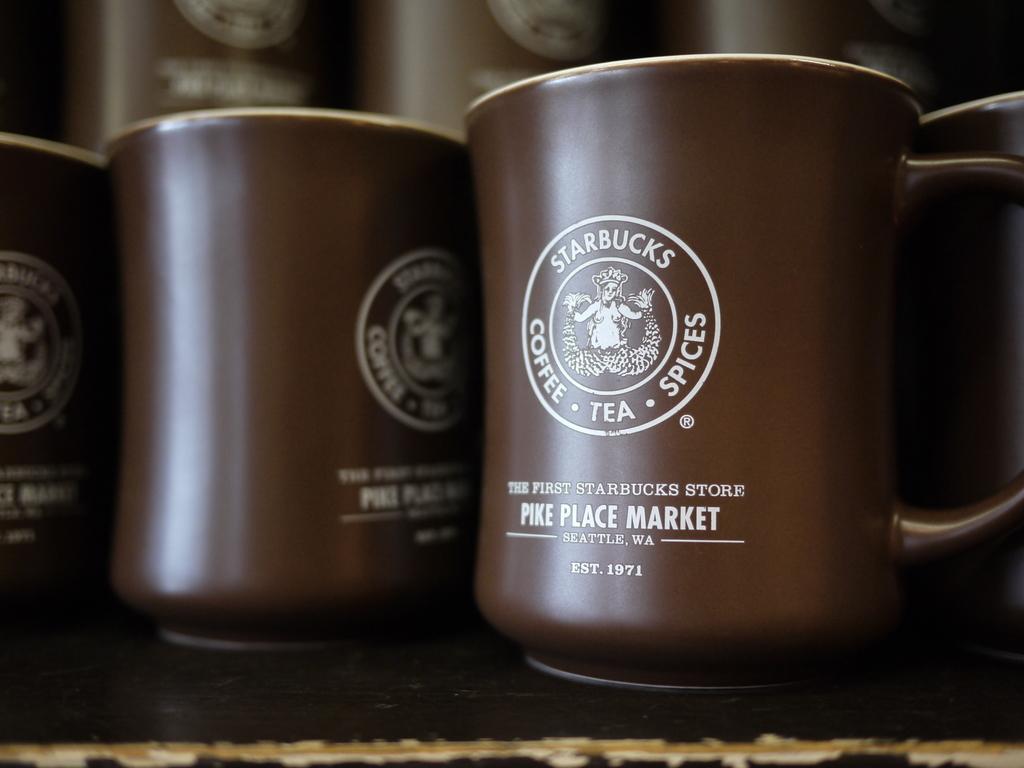What store uses this mug?
Your answer should be compact. Starbucks. Coffee tea and what?
Provide a short and direct response. Spices. 